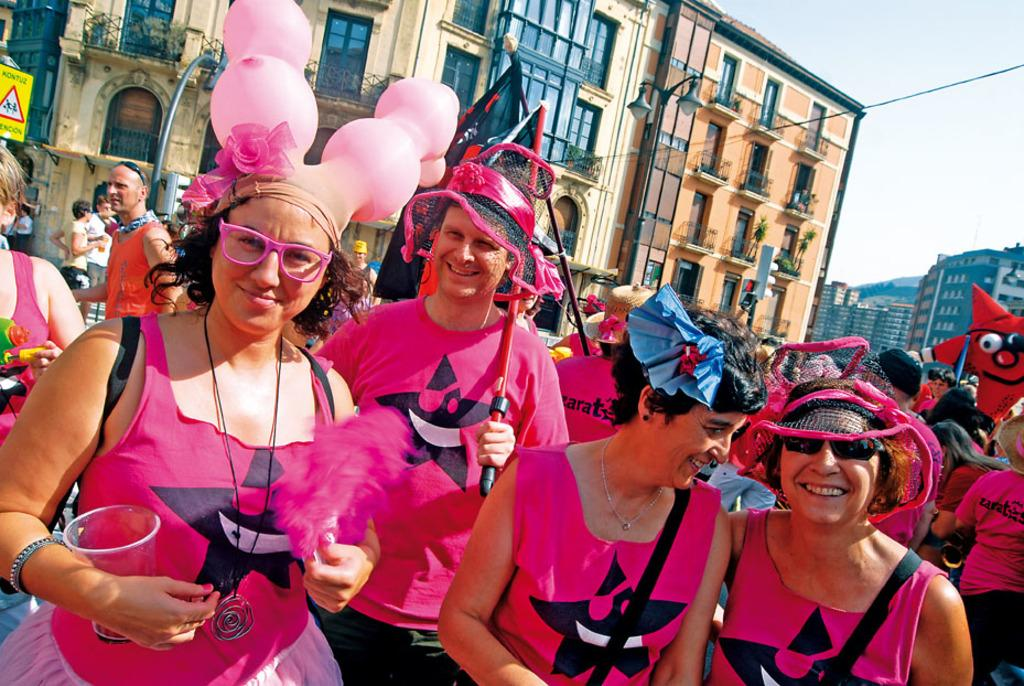What are the people in the image doing? The people in the image are standing and smiling. What can be seen in the background of the image? There is a building in the background of the image. What is the condition of the sky in the image? The sky is clear in the image. What type of camera can be seen in the image? There is no camera present in the image. How many drawers are visible in the image? There are no drawers present in the image. 